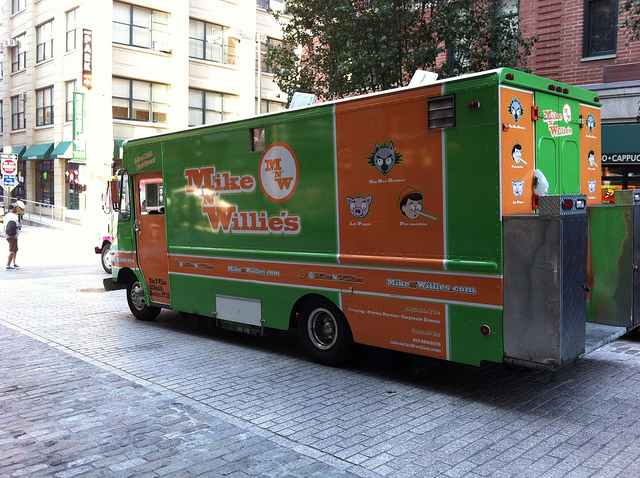Please transcribe the text information in this image. Mike N Wille's O-CAPPUC Willies N Mike M PARK 